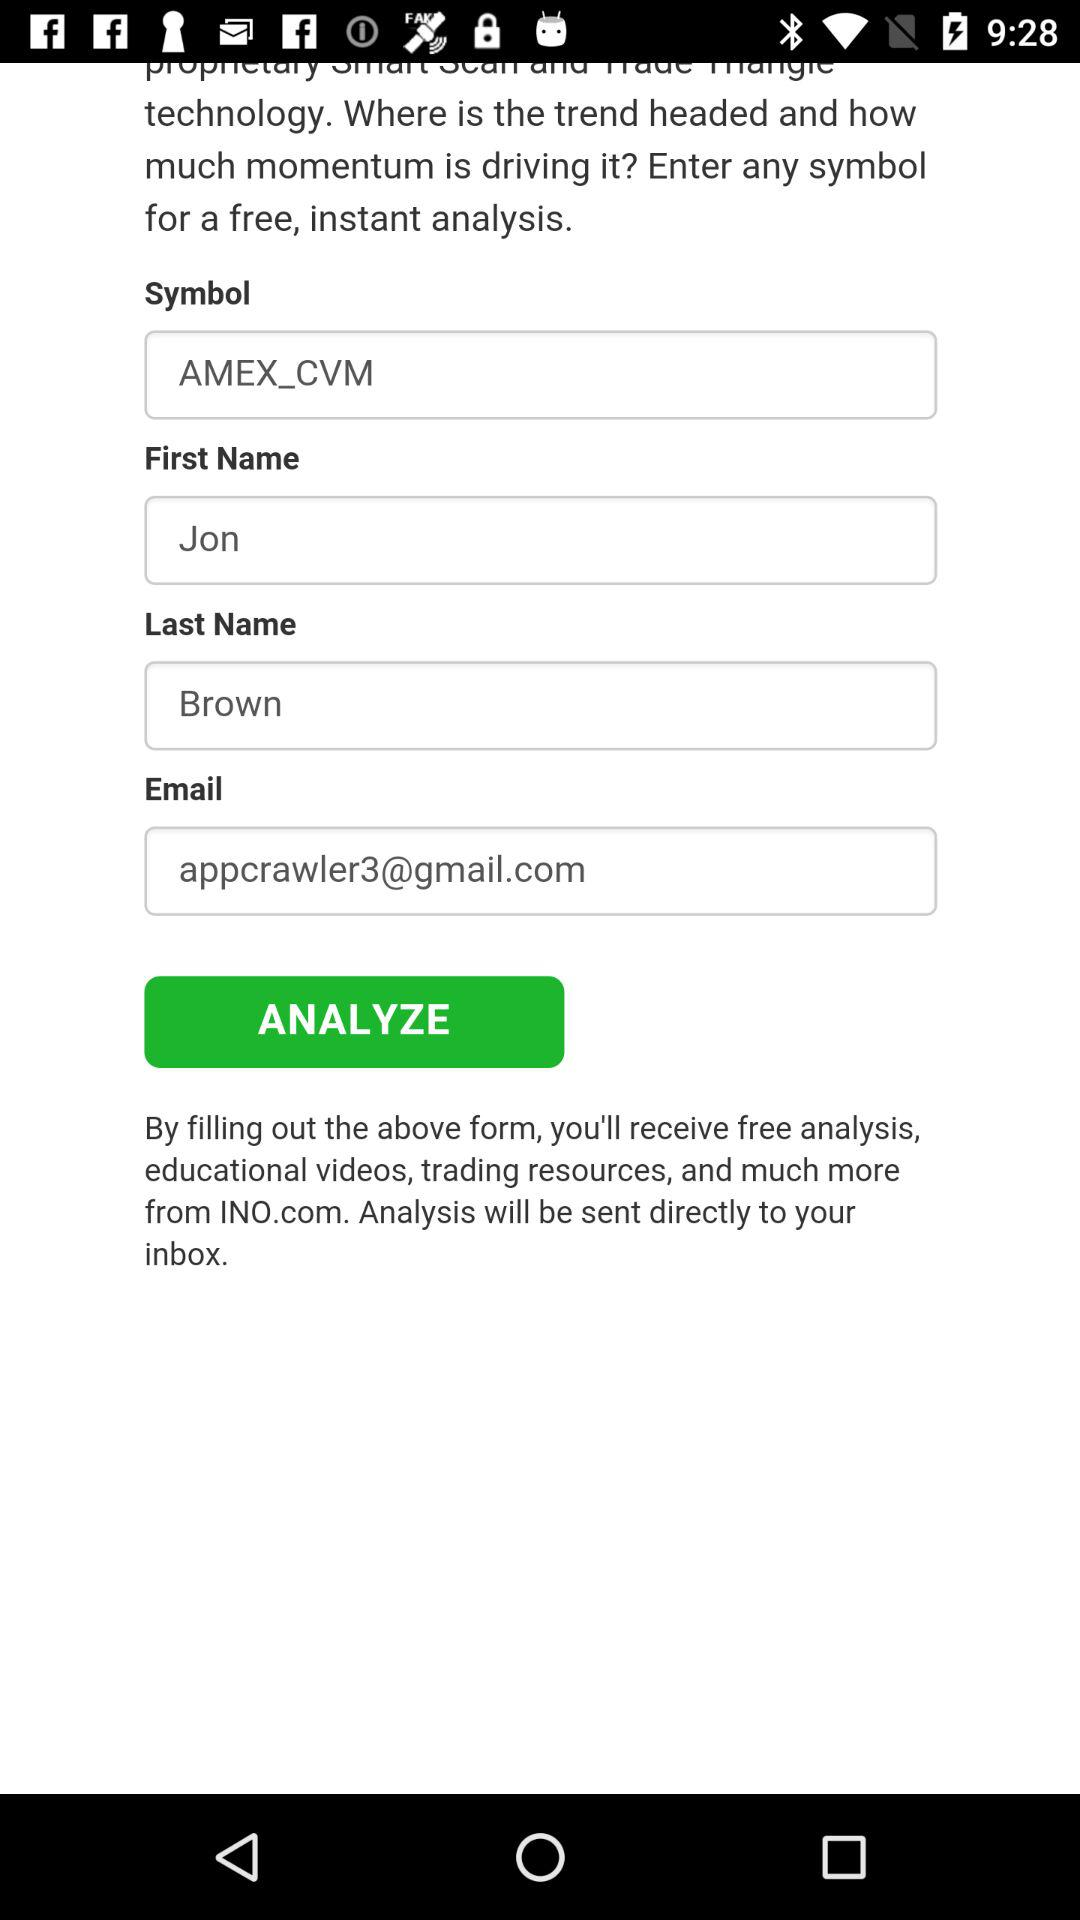What is the entered symbol? The entered symbol is AMEX_CVM. 